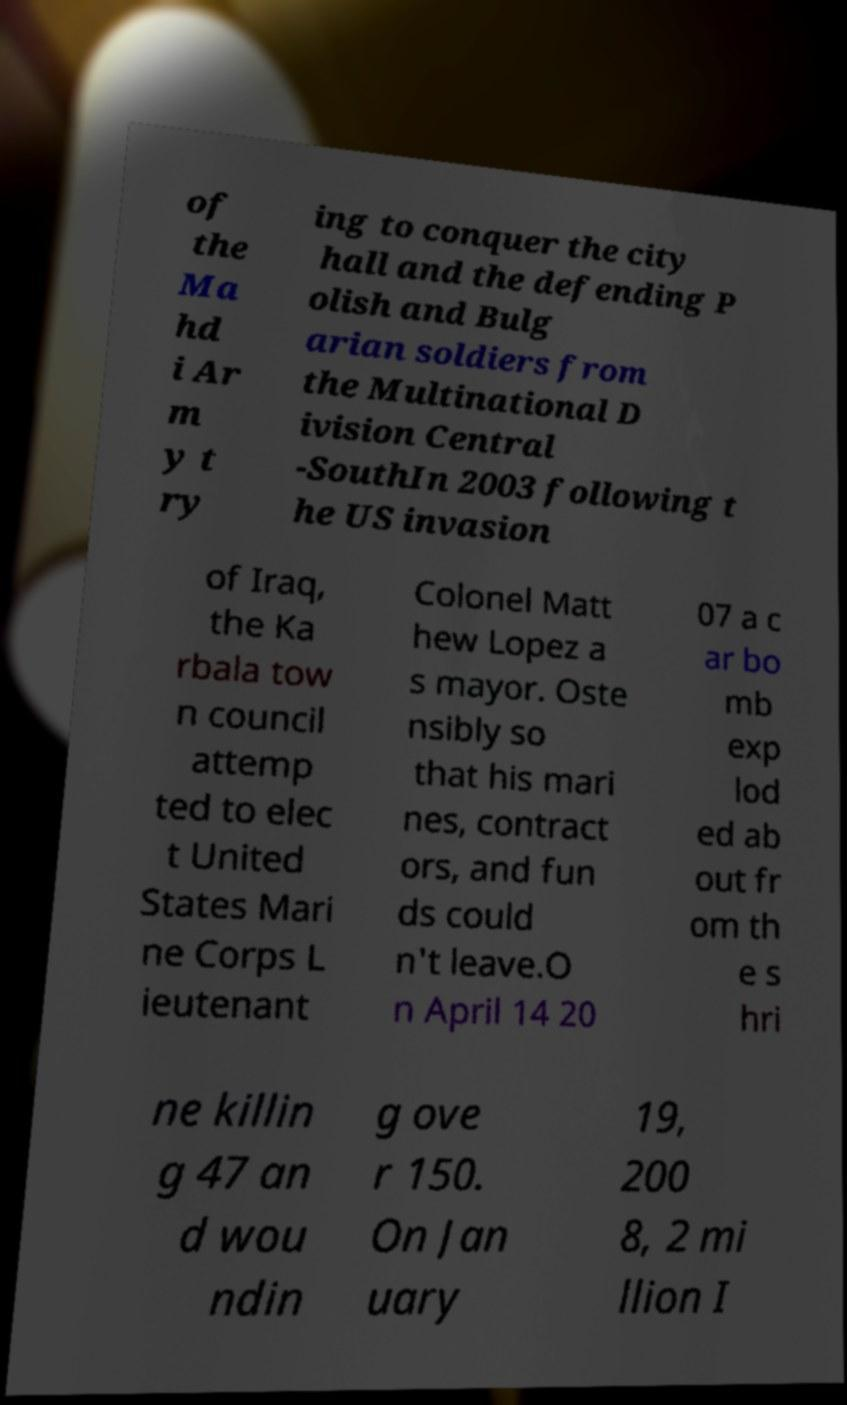Could you extract and type out the text from this image? of the Ma hd i Ar m y t ry ing to conquer the city hall and the defending P olish and Bulg arian soldiers from the Multinational D ivision Central -SouthIn 2003 following t he US invasion of Iraq, the Ka rbala tow n council attemp ted to elec t United States Mari ne Corps L ieutenant Colonel Matt hew Lopez a s mayor. Oste nsibly so that his mari nes, contract ors, and fun ds could n't leave.O n April 14 20 07 a c ar bo mb exp lod ed ab out fr om th e s hri ne killin g 47 an d wou ndin g ove r 150. On Jan uary 19, 200 8, 2 mi llion I 